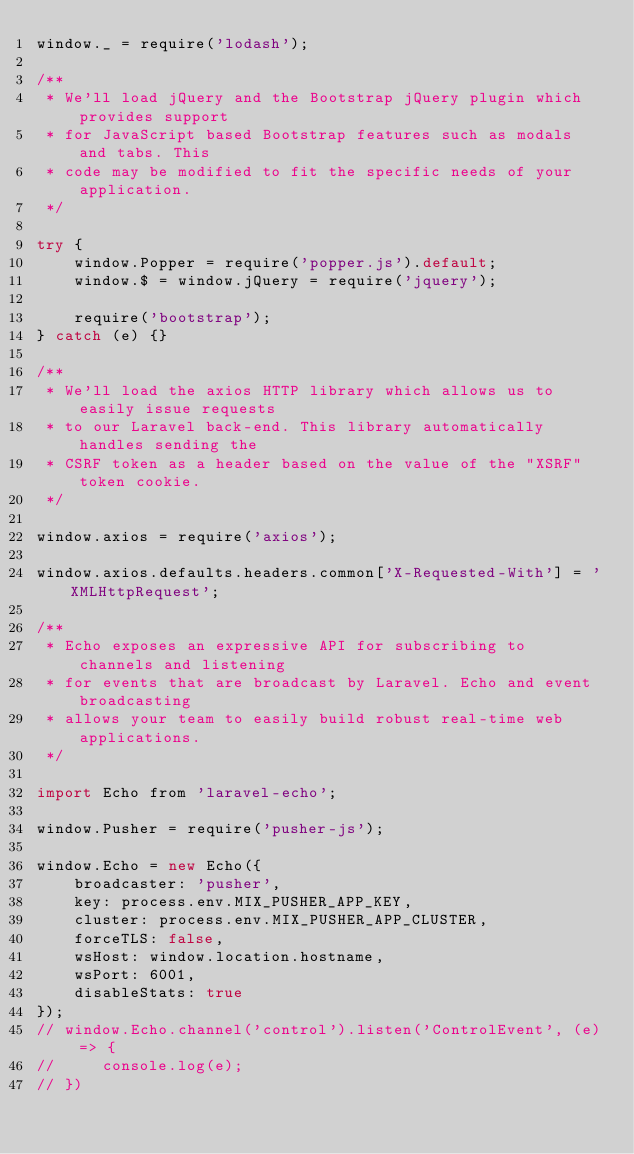Convert code to text. <code><loc_0><loc_0><loc_500><loc_500><_JavaScript_>window._ = require('lodash');

/**
 * We'll load jQuery and the Bootstrap jQuery plugin which provides support
 * for JavaScript based Bootstrap features such as modals and tabs. This
 * code may be modified to fit the specific needs of your application.
 */

try {
    window.Popper = require('popper.js').default;
    window.$ = window.jQuery = require('jquery');

    require('bootstrap');
} catch (e) {}

/**
 * We'll load the axios HTTP library which allows us to easily issue requests
 * to our Laravel back-end. This library automatically handles sending the
 * CSRF token as a header based on the value of the "XSRF" token cookie.
 */

window.axios = require('axios');

window.axios.defaults.headers.common['X-Requested-With'] = 'XMLHttpRequest';

/**
 * Echo exposes an expressive API for subscribing to channels and listening
 * for events that are broadcast by Laravel. Echo and event broadcasting
 * allows your team to easily build robust real-time web applications.
 */

import Echo from 'laravel-echo';

window.Pusher = require('pusher-js');

window.Echo = new Echo({
    broadcaster: 'pusher',
    key: process.env.MIX_PUSHER_APP_KEY,
    cluster: process.env.MIX_PUSHER_APP_CLUSTER,
    forceTLS: false,
    wsHost: window.location.hostname,
    wsPort: 6001,
    disableStats: true
});
// window.Echo.channel('control').listen('ControlEvent', (e) => {
//     console.log(e);
// })
</code> 